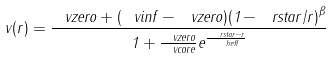<formula> <loc_0><loc_0><loc_500><loc_500>v ( r ) = \frac { \ v z e r o + ( \ v i n f - \ v z e r o ) { ( 1 - \ r s t a r / r ) } ^ { \beta } } { 1 + \frac { \ v z e r o } { \ v c o r e } e ^ { \frac { \ r s t a r - r } { \ h e f f } } }</formula> 